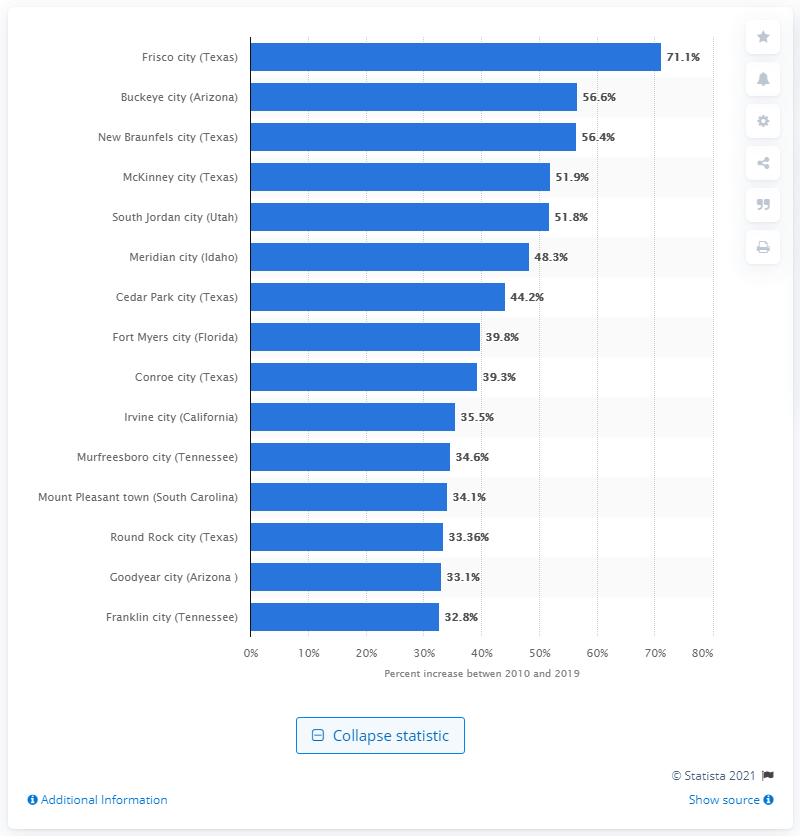Give some essential details in this illustration. According to recent data, the growth rate of Frisco is 71.1%. 